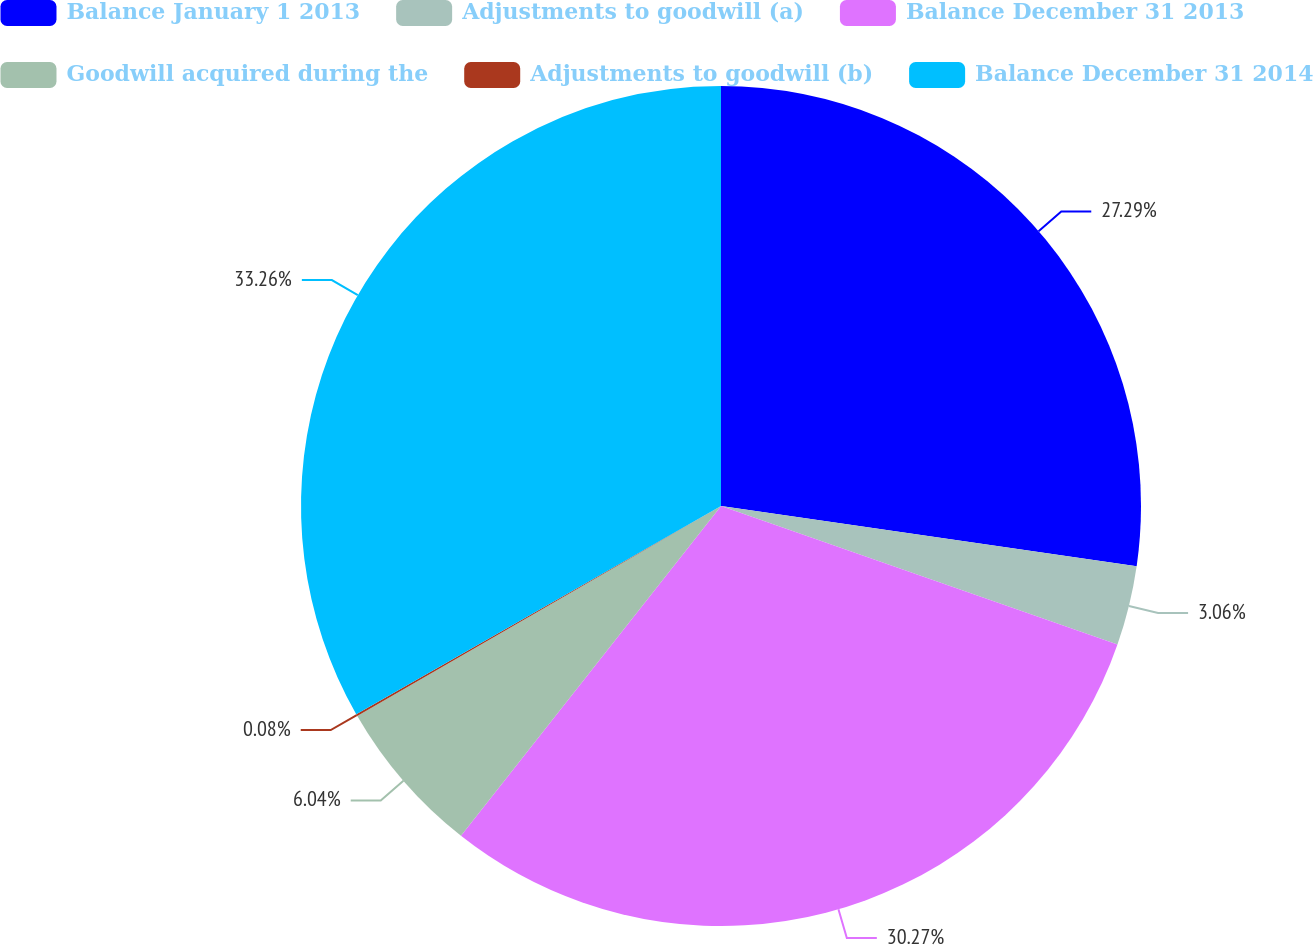Convert chart. <chart><loc_0><loc_0><loc_500><loc_500><pie_chart><fcel>Balance January 1 2013<fcel>Adjustments to goodwill (a)<fcel>Balance December 31 2013<fcel>Goodwill acquired during the<fcel>Adjustments to goodwill (b)<fcel>Balance December 31 2014<nl><fcel>27.29%<fcel>3.06%<fcel>30.27%<fcel>6.04%<fcel>0.08%<fcel>33.25%<nl></chart> 